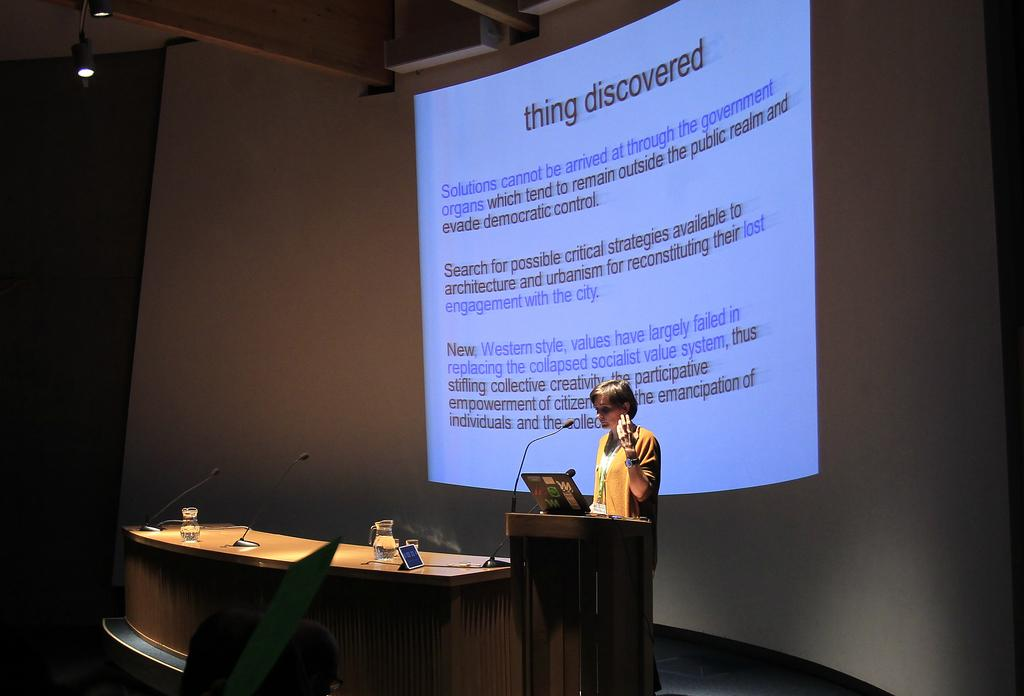Who is the main subject in the image? There is a woman in the center of the image. What object is in front of the woman? There is a wooden stand in front of the woman. What items are on the wooden stand? A tablet and a microphone are present on the wooden stand. What can be seen behind the woman? There is a screen visible behind the woman. How many horses are present in the image? There are no horses present in the image. What territory is being discussed by the woman in the image? The image does not provide any information about a territory being discussed. 